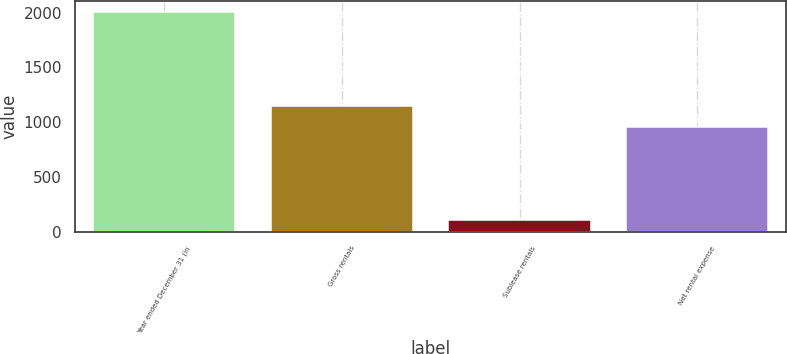<chart> <loc_0><loc_0><loc_500><loc_500><bar_chart><fcel>Year ended December 31 (in<fcel>Gross rentals<fcel>Sublease rentals<fcel>Net rental expense<nl><fcel>2003<fcel>1144.7<fcel>106<fcel>955<nl></chart> 